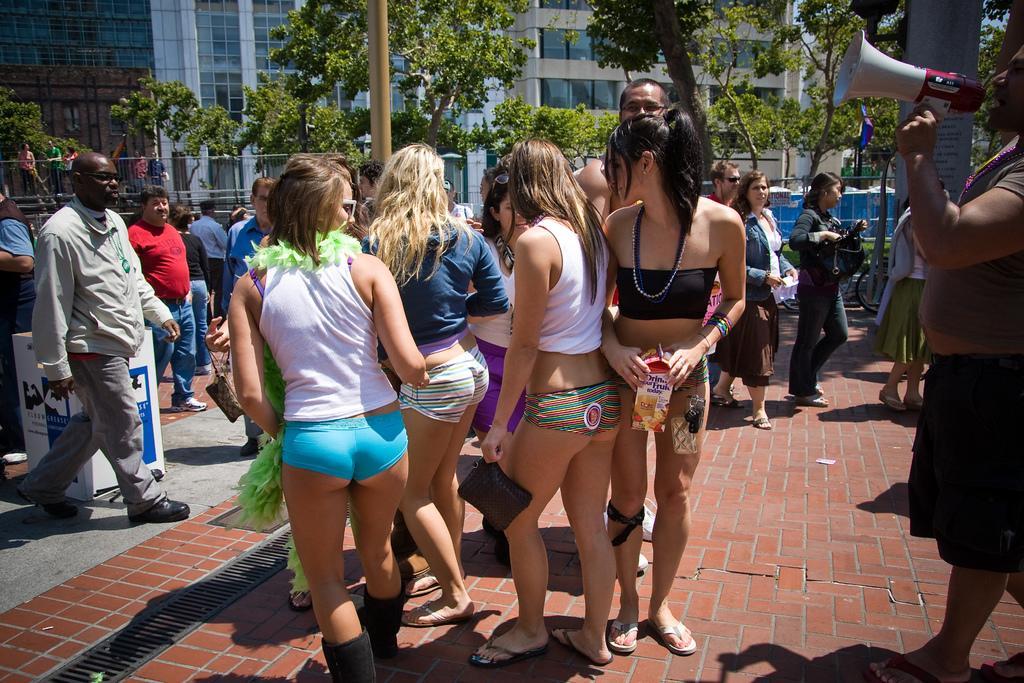Could you give a brief overview of what you see in this image? In this image, I can see a group of people standing and few people walking. On the right side of the image, I can see a person holding a megaphone and there is a board. On the left side of the image, there is an object behind the person. In the background, I can see the iron grilles, buildings, trees and a pole. 